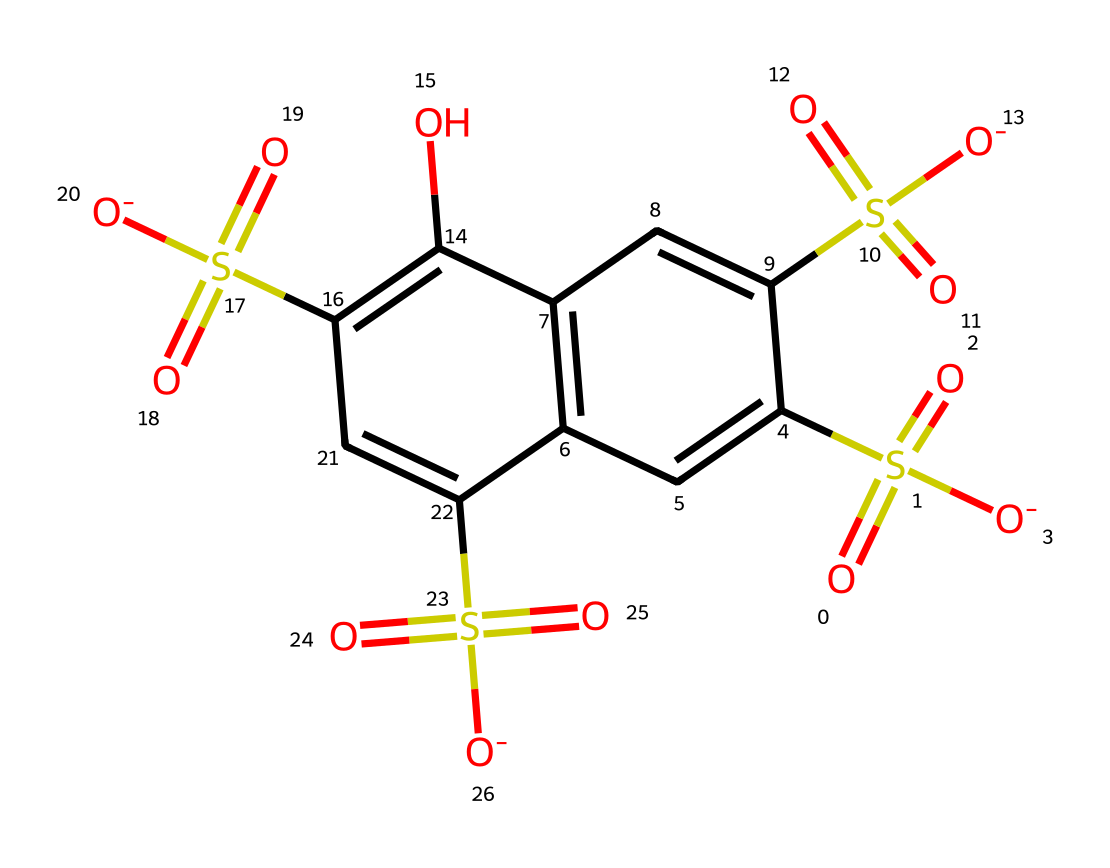how many sulfur atoms are present in this molecule? By examining the SMILES representation, we can count the number of sulfur atoms (S) indicated in the structure. The molecule has four instances of 'S', which represent sulfur atoms.
Answer: four what is the main functional group present in this chemical? The structure contains sulfonic acid groups (–SO3H) as indicated by the presence of multiple sulfur atoms bonded to oxygen and negatively charged oxygen. These groups are characteristic of sulfonic acids.
Answer: sulfonic acid how many hydroxyl groups are in the molecule? In the chemical structure, hydroxyl groups (–OH) are indicated by 'O' connected to any carbon. There are 2 instances of 'O' that are bonded to carbon atoms in the structure, indicating the presence of two hydroxyl groups.
Answer: two what type of compound is this chemical classified as? The presence of multiple sulfonic acid groups and color properties aligns this compound with the classification of synthetic dyes, specifically yellow dyes used in highlighters.
Answer: dye what is the primary characteristic that gives this yellow highlighter ink its color? The presence of the sulfur-containing groups contributes to the overall electronic structure, which affects the absorption of specific wavelengths of light, leading to the visualization of yellow color. This characteristic aligns with the absorption properties of the electrons in the conjugated system of aromatic compounds.
Answer: electronic structure 